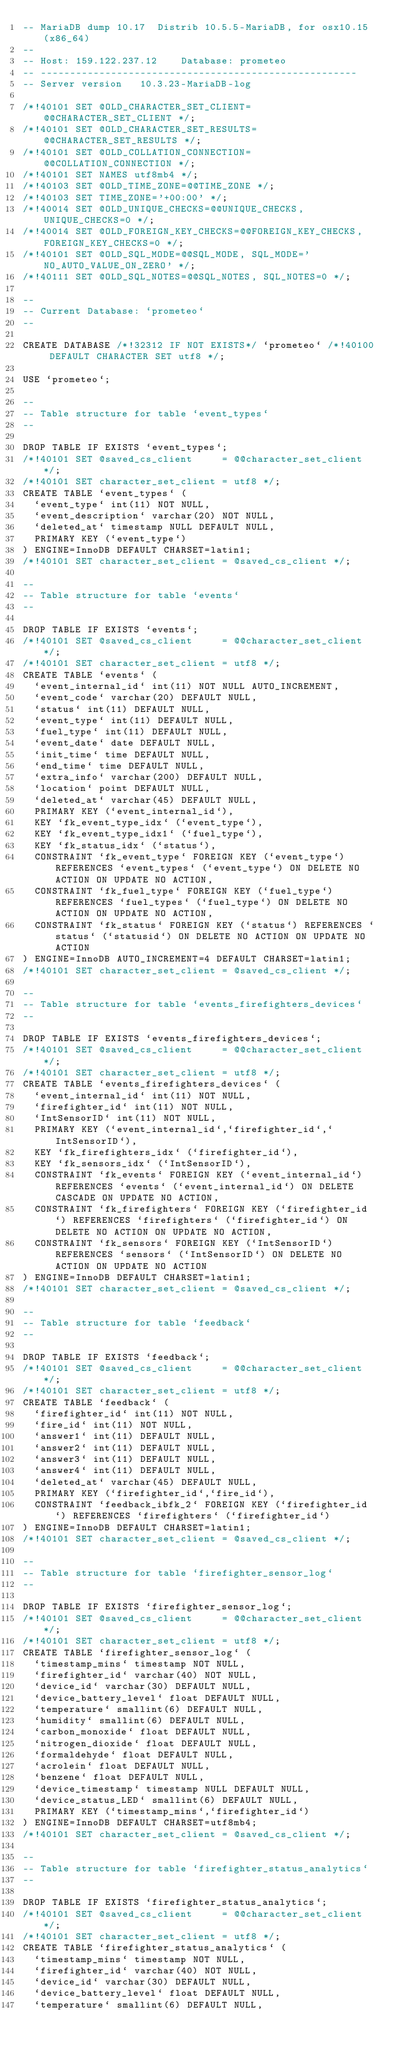Convert code to text. <code><loc_0><loc_0><loc_500><loc_500><_SQL_>-- MariaDB dump 10.17  Distrib 10.5.5-MariaDB, for osx10.15 (x86_64)
--
-- Host: 159.122.237.12    Database: prometeo
-- ------------------------------------------------------
-- Server version	10.3.23-MariaDB-log

/*!40101 SET @OLD_CHARACTER_SET_CLIENT=@@CHARACTER_SET_CLIENT */;
/*!40101 SET @OLD_CHARACTER_SET_RESULTS=@@CHARACTER_SET_RESULTS */;
/*!40101 SET @OLD_COLLATION_CONNECTION=@@COLLATION_CONNECTION */;
/*!40101 SET NAMES utf8mb4 */;
/*!40103 SET @OLD_TIME_ZONE=@@TIME_ZONE */;
/*!40103 SET TIME_ZONE='+00:00' */;
/*!40014 SET @OLD_UNIQUE_CHECKS=@@UNIQUE_CHECKS, UNIQUE_CHECKS=0 */;
/*!40014 SET @OLD_FOREIGN_KEY_CHECKS=@@FOREIGN_KEY_CHECKS, FOREIGN_KEY_CHECKS=0 */;
/*!40101 SET @OLD_SQL_MODE=@@SQL_MODE, SQL_MODE='NO_AUTO_VALUE_ON_ZERO' */;
/*!40111 SET @OLD_SQL_NOTES=@@SQL_NOTES, SQL_NOTES=0 */;

--
-- Current Database: `prometeo`
--

CREATE DATABASE /*!32312 IF NOT EXISTS*/ `prometeo` /*!40100 DEFAULT CHARACTER SET utf8 */;

USE `prometeo`;

--
-- Table structure for table `event_types`
--

DROP TABLE IF EXISTS `event_types`;
/*!40101 SET @saved_cs_client     = @@character_set_client */;
/*!40101 SET character_set_client = utf8 */;
CREATE TABLE `event_types` (
  `event_type` int(11) NOT NULL,
  `event_description` varchar(20) NOT NULL,
  `deleted_at` timestamp NULL DEFAULT NULL,
  PRIMARY KEY (`event_type`)
) ENGINE=InnoDB DEFAULT CHARSET=latin1;
/*!40101 SET character_set_client = @saved_cs_client */;

--
-- Table structure for table `events`
--

DROP TABLE IF EXISTS `events`;
/*!40101 SET @saved_cs_client     = @@character_set_client */;
/*!40101 SET character_set_client = utf8 */;
CREATE TABLE `events` (
  `event_internal_id` int(11) NOT NULL AUTO_INCREMENT,
  `event_code` varchar(20) DEFAULT NULL,
  `status` int(11) DEFAULT NULL,
  `event_type` int(11) DEFAULT NULL,
  `fuel_type` int(11) DEFAULT NULL,
  `event_date` date DEFAULT NULL,
  `init_time` time DEFAULT NULL,
  `end_time` time DEFAULT NULL,
  `extra_info` varchar(200) DEFAULT NULL,
  `location` point DEFAULT NULL,
  `deleted_at` varchar(45) DEFAULT NULL,
  PRIMARY KEY (`event_internal_id`),
  KEY `fk_event_type_idx` (`event_type`),
  KEY `fk_event_type_idx1` (`fuel_type`),
  KEY `fk_status_idx` (`status`),
  CONSTRAINT `fk_event_type` FOREIGN KEY (`event_type`) REFERENCES `event_types` (`event_type`) ON DELETE NO ACTION ON UPDATE NO ACTION,
  CONSTRAINT `fk_fuel_type` FOREIGN KEY (`fuel_type`) REFERENCES `fuel_types` (`fuel_type`) ON DELETE NO ACTION ON UPDATE NO ACTION,
  CONSTRAINT `fk_status` FOREIGN KEY (`status`) REFERENCES `status` (`statusid`) ON DELETE NO ACTION ON UPDATE NO ACTION
) ENGINE=InnoDB AUTO_INCREMENT=4 DEFAULT CHARSET=latin1;
/*!40101 SET character_set_client = @saved_cs_client */;

--
-- Table structure for table `events_firefighters_devices`
--

DROP TABLE IF EXISTS `events_firefighters_devices`;
/*!40101 SET @saved_cs_client     = @@character_set_client */;
/*!40101 SET character_set_client = utf8 */;
CREATE TABLE `events_firefighters_devices` (
  `event_internal_id` int(11) NOT NULL,
  `firefighter_id` int(11) NOT NULL,
  `IntSensorID` int(11) NOT NULL,
  PRIMARY KEY (`event_internal_id`,`firefighter_id`,`IntSensorID`),
  KEY `fk_firefighters_idx` (`firefighter_id`),
  KEY `fk_sensors_idx` (`IntSensorID`),
  CONSTRAINT `fk_events` FOREIGN KEY (`event_internal_id`) REFERENCES `events` (`event_internal_id`) ON DELETE CASCADE ON UPDATE NO ACTION,
  CONSTRAINT `fk_firefighters` FOREIGN KEY (`firefighter_id`) REFERENCES `firefighters` (`firefighter_id`) ON DELETE NO ACTION ON UPDATE NO ACTION,
  CONSTRAINT `fk_sensors` FOREIGN KEY (`IntSensorID`) REFERENCES `sensors` (`IntSensorID`) ON DELETE NO ACTION ON UPDATE NO ACTION
) ENGINE=InnoDB DEFAULT CHARSET=latin1;
/*!40101 SET character_set_client = @saved_cs_client */;

--
-- Table structure for table `feedback`
--

DROP TABLE IF EXISTS `feedback`;
/*!40101 SET @saved_cs_client     = @@character_set_client */;
/*!40101 SET character_set_client = utf8 */;
CREATE TABLE `feedback` (
  `firefighter_id` int(11) NOT NULL,
  `fire_id` int(11) NOT NULL,
  `answer1` int(11) DEFAULT NULL,
  `answer2` int(11) DEFAULT NULL,
  `answer3` int(11) DEFAULT NULL,
  `answer4` int(11) DEFAULT NULL,
  `deleted_at` varchar(45) DEFAULT NULL,
  PRIMARY KEY (`firefighter_id`,`fire_id`),
  CONSTRAINT `feedback_ibfk_2` FOREIGN KEY (`firefighter_id`) REFERENCES `firefighters` (`firefighter_id`)
) ENGINE=InnoDB DEFAULT CHARSET=latin1;
/*!40101 SET character_set_client = @saved_cs_client */;

--
-- Table structure for table `firefighter_sensor_log`
--

DROP TABLE IF EXISTS `firefighter_sensor_log`;
/*!40101 SET @saved_cs_client     = @@character_set_client */;
/*!40101 SET character_set_client = utf8 */;
CREATE TABLE `firefighter_sensor_log` (
  `timestamp_mins` timestamp NOT NULL,
  `firefighter_id` varchar(40) NOT NULL,
  `device_id` varchar(30) DEFAULT NULL,
  `device_battery_level` float DEFAULT NULL,
  `temperature` smallint(6) DEFAULT NULL,
  `humidity` smallint(6) DEFAULT NULL,
  `carbon_monoxide` float DEFAULT NULL,
  `nitrogen_dioxide` float DEFAULT NULL,
  `formaldehyde` float DEFAULT NULL,
  `acrolein` float DEFAULT NULL,
  `benzene` float DEFAULT NULL,
  `device_timestamp` timestamp NULL DEFAULT NULL,
  `device_status_LED` smallint(6) DEFAULT NULL,
  PRIMARY KEY (`timestamp_mins`,`firefighter_id`)
) ENGINE=InnoDB DEFAULT CHARSET=utf8mb4;
/*!40101 SET character_set_client = @saved_cs_client */;

--
-- Table structure for table `firefighter_status_analytics`
--

DROP TABLE IF EXISTS `firefighter_status_analytics`;
/*!40101 SET @saved_cs_client     = @@character_set_client */;
/*!40101 SET character_set_client = utf8 */;
CREATE TABLE `firefighter_status_analytics` (
  `timestamp_mins` timestamp NOT NULL,
  `firefighter_id` varchar(40) NOT NULL,
  `device_id` varchar(30) DEFAULT NULL,
  `device_battery_level` float DEFAULT NULL,
  `temperature` smallint(6) DEFAULT NULL,</code> 